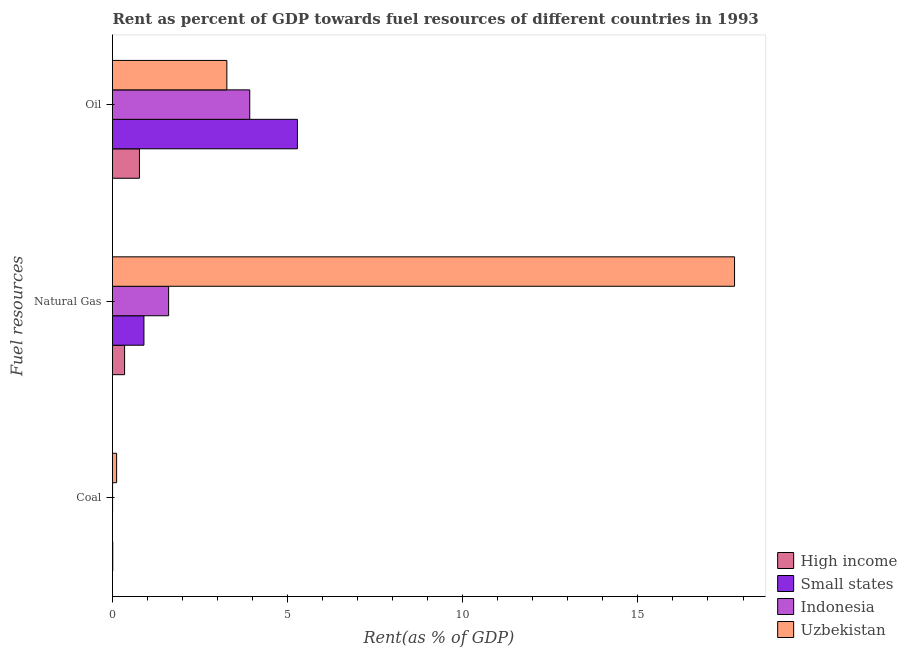How many different coloured bars are there?
Provide a short and direct response. 4. How many groups of bars are there?
Give a very brief answer. 3. Are the number of bars per tick equal to the number of legend labels?
Keep it short and to the point. Yes. Are the number of bars on each tick of the Y-axis equal?
Your answer should be very brief. Yes. How many bars are there on the 2nd tick from the bottom?
Provide a short and direct response. 4. What is the label of the 1st group of bars from the top?
Your response must be concise. Oil. What is the rent towards natural gas in High income?
Keep it short and to the point. 0.35. Across all countries, what is the maximum rent towards natural gas?
Offer a very short reply. 17.76. Across all countries, what is the minimum rent towards coal?
Your answer should be very brief. 0. In which country was the rent towards natural gas maximum?
Offer a very short reply. Uzbekistan. What is the total rent towards natural gas in the graph?
Make the answer very short. 20.6. What is the difference between the rent towards coal in Indonesia and that in High income?
Your answer should be very brief. -0. What is the difference between the rent towards natural gas in Uzbekistan and the rent towards coal in Small states?
Make the answer very short. 17.76. What is the average rent towards oil per country?
Offer a very short reply. 3.31. What is the difference between the rent towards natural gas and rent towards coal in High income?
Your answer should be compact. 0.34. In how many countries, is the rent towards coal greater than 1 %?
Provide a short and direct response. 0. What is the ratio of the rent towards natural gas in High income to that in Indonesia?
Offer a terse response. 0.22. Is the rent towards oil in Small states less than that in Uzbekistan?
Keep it short and to the point. No. What is the difference between the highest and the second highest rent towards oil?
Keep it short and to the point. 1.36. What is the difference between the highest and the lowest rent towards coal?
Provide a short and direct response. 0.12. In how many countries, is the rent towards coal greater than the average rent towards coal taken over all countries?
Make the answer very short. 1. Is the sum of the rent towards oil in Indonesia and Small states greater than the maximum rent towards coal across all countries?
Your answer should be very brief. Yes. What does the 1st bar from the top in Oil represents?
Make the answer very short. Uzbekistan. What does the 2nd bar from the bottom in Oil represents?
Keep it short and to the point. Small states. Is it the case that in every country, the sum of the rent towards coal and rent towards natural gas is greater than the rent towards oil?
Your answer should be very brief. No. What is the difference between two consecutive major ticks on the X-axis?
Provide a short and direct response. 5. Are the values on the major ticks of X-axis written in scientific E-notation?
Offer a very short reply. No. How many legend labels are there?
Offer a terse response. 4. What is the title of the graph?
Give a very brief answer. Rent as percent of GDP towards fuel resources of different countries in 1993. Does "Hungary" appear as one of the legend labels in the graph?
Your answer should be compact. No. What is the label or title of the X-axis?
Provide a short and direct response. Rent(as % of GDP). What is the label or title of the Y-axis?
Provide a succinct answer. Fuel resources. What is the Rent(as % of GDP) of High income in Coal?
Provide a short and direct response. 0.01. What is the Rent(as % of GDP) in Small states in Coal?
Your answer should be very brief. 0. What is the Rent(as % of GDP) of Indonesia in Coal?
Make the answer very short. 0. What is the Rent(as % of GDP) in Uzbekistan in Coal?
Provide a succinct answer. 0.12. What is the Rent(as % of GDP) of High income in Natural Gas?
Your answer should be very brief. 0.35. What is the Rent(as % of GDP) in Small states in Natural Gas?
Provide a short and direct response. 0.9. What is the Rent(as % of GDP) of Indonesia in Natural Gas?
Give a very brief answer. 1.6. What is the Rent(as % of GDP) of Uzbekistan in Natural Gas?
Offer a very short reply. 17.76. What is the Rent(as % of GDP) in High income in Oil?
Provide a succinct answer. 0.77. What is the Rent(as % of GDP) in Small states in Oil?
Ensure brevity in your answer.  5.28. What is the Rent(as % of GDP) in Indonesia in Oil?
Your answer should be very brief. 3.92. What is the Rent(as % of GDP) of Uzbekistan in Oil?
Keep it short and to the point. 3.26. Across all Fuel resources, what is the maximum Rent(as % of GDP) of High income?
Offer a terse response. 0.77. Across all Fuel resources, what is the maximum Rent(as % of GDP) in Small states?
Provide a succinct answer. 5.28. Across all Fuel resources, what is the maximum Rent(as % of GDP) in Indonesia?
Keep it short and to the point. 3.92. Across all Fuel resources, what is the maximum Rent(as % of GDP) of Uzbekistan?
Your response must be concise. 17.76. Across all Fuel resources, what is the minimum Rent(as % of GDP) in High income?
Offer a very short reply. 0.01. Across all Fuel resources, what is the minimum Rent(as % of GDP) of Small states?
Your answer should be very brief. 0. Across all Fuel resources, what is the minimum Rent(as % of GDP) in Indonesia?
Offer a very short reply. 0. Across all Fuel resources, what is the minimum Rent(as % of GDP) of Uzbekistan?
Your response must be concise. 0.12. What is the total Rent(as % of GDP) in High income in the graph?
Your answer should be very brief. 1.12. What is the total Rent(as % of GDP) of Small states in the graph?
Make the answer very short. 6.18. What is the total Rent(as % of GDP) in Indonesia in the graph?
Your answer should be very brief. 5.52. What is the total Rent(as % of GDP) in Uzbekistan in the graph?
Make the answer very short. 21.14. What is the difference between the Rent(as % of GDP) in High income in Coal and that in Natural Gas?
Your answer should be very brief. -0.34. What is the difference between the Rent(as % of GDP) in Small states in Coal and that in Natural Gas?
Your response must be concise. -0.9. What is the difference between the Rent(as % of GDP) of Indonesia in Coal and that in Natural Gas?
Keep it short and to the point. -1.6. What is the difference between the Rent(as % of GDP) of Uzbekistan in Coal and that in Natural Gas?
Your answer should be very brief. -17.64. What is the difference between the Rent(as % of GDP) in High income in Coal and that in Oil?
Give a very brief answer. -0.76. What is the difference between the Rent(as % of GDP) of Small states in Coal and that in Oil?
Your answer should be compact. -5.28. What is the difference between the Rent(as % of GDP) in Indonesia in Coal and that in Oil?
Give a very brief answer. -3.92. What is the difference between the Rent(as % of GDP) of Uzbekistan in Coal and that in Oil?
Provide a short and direct response. -3.15. What is the difference between the Rent(as % of GDP) in High income in Natural Gas and that in Oil?
Make the answer very short. -0.42. What is the difference between the Rent(as % of GDP) of Small states in Natural Gas and that in Oil?
Your answer should be compact. -4.38. What is the difference between the Rent(as % of GDP) in Indonesia in Natural Gas and that in Oil?
Your response must be concise. -2.32. What is the difference between the Rent(as % of GDP) of Uzbekistan in Natural Gas and that in Oil?
Your response must be concise. 14.49. What is the difference between the Rent(as % of GDP) of High income in Coal and the Rent(as % of GDP) of Small states in Natural Gas?
Offer a very short reply. -0.89. What is the difference between the Rent(as % of GDP) in High income in Coal and the Rent(as % of GDP) in Indonesia in Natural Gas?
Make the answer very short. -1.6. What is the difference between the Rent(as % of GDP) in High income in Coal and the Rent(as % of GDP) in Uzbekistan in Natural Gas?
Ensure brevity in your answer.  -17.75. What is the difference between the Rent(as % of GDP) of Small states in Coal and the Rent(as % of GDP) of Indonesia in Natural Gas?
Keep it short and to the point. -1.6. What is the difference between the Rent(as % of GDP) in Small states in Coal and the Rent(as % of GDP) in Uzbekistan in Natural Gas?
Give a very brief answer. -17.76. What is the difference between the Rent(as % of GDP) of Indonesia in Coal and the Rent(as % of GDP) of Uzbekistan in Natural Gas?
Your response must be concise. -17.76. What is the difference between the Rent(as % of GDP) of High income in Coal and the Rent(as % of GDP) of Small states in Oil?
Provide a short and direct response. -5.27. What is the difference between the Rent(as % of GDP) in High income in Coal and the Rent(as % of GDP) in Indonesia in Oil?
Provide a succinct answer. -3.91. What is the difference between the Rent(as % of GDP) of High income in Coal and the Rent(as % of GDP) of Uzbekistan in Oil?
Provide a short and direct response. -3.26. What is the difference between the Rent(as % of GDP) in Small states in Coal and the Rent(as % of GDP) in Indonesia in Oil?
Provide a succinct answer. -3.92. What is the difference between the Rent(as % of GDP) of Small states in Coal and the Rent(as % of GDP) of Uzbekistan in Oil?
Ensure brevity in your answer.  -3.26. What is the difference between the Rent(as % of GDP) of Indonesia in Coal and the Rent(as % of GDP) of Uzbekistan in Oil?
Offer a very short reply. -3.26. What is the difference between the Rent(as % of GDP) in High income in Natural Gas and the Rent(as % of GDP) in Small states in Oil?
Make the answer very short. -4.93. What is the difference between the Rent(as % of GDP) of High income in Natural Gas and the Rent(as % of GDP) of Indonesia in Oil?
Give a very brief answer. -3.57. What is the difference between the Rent(as % of GDP) of High income in Natural Gas and the Rent(as % of GDP) of Uzbekistan in Oil?
Offer a terse response. -2.92. What is the difference between the Rent(as % of GDP) of Small states in Natural Gas and the Rent(as % of GDP) of Indonesia in Oil?
Your answer should be very brief. -3.02. What is the difference between the Rent(as % of GDP) of Small states in Natural Gas and the Rent(as % of GDP) of Uzbekistan in Oil?
Ensure brevity in your answer.  -2.37. What is the difference between the Rent(as % of GDP) in Indonesia in Natural Gas and the Rent(as % of GDP) in Uzbekistan in Oil?
Provide a succinct answer. -1.66. What is the average Rent(as % of GDP) in High income per Fuel resources?
Give a very brief answer. 0.37. What is the average Rent(as % of GDP) of Small states per Fuel resources?
Offer a terse response. 2.06. What is the average Rent(as % of GDP) in Indonesia per Fuel resources?
Offer a terse response. 1.84. What is the average Rent(as % of GDP) in Uzbekistan per Fuel resources?
Give a very brief answer. 7.05. What is the difference between the Rent(as % of GDP) of High income and Rent(as % of GDP) of Small states in Coal?
Your response must be concise. 0.01. What is the difference between the Rent(as % of GDP) in High income and Rent(as % of GDP) in Indonesia in Coal?
Provide a succinct answer. 0. What is the difference between the Rent(as % of GDP) of High income and Rent(as % of GDP) of Uzbekistan in Coal?
Offer a very short reply. -0.11. What is the difference between the Rent(as % of GDP) in Small states and Rent(as % of GDP) in Indonesia in Coal?
Offer a terse response. -0. What is the difference between the Rent(as % of GDP) in Small states and Rent(as % of GDP) in Uzbekistan in Coal?
Keep it short and to the point. -0.12. What is the difference between the Rent(as % of GDP) in Indonesia and Rent(as % of GDP) in Uzbekistan in Coal?
Keep it short and to the point. -0.12. What is the difference between the Rent(as % of GDP) in High income and Rent(as % of GDP) in Small states in Natural Gas?
Keep it short and to the point. -0.55. What is the difference between the Rent(as % of GDP) of High income and Rent(as % of GDP) of Indonesia in Natural Gas?
Make the answer very short. -1.26. What is the difference between the Rent(as % of GDP) in High income and Rent(as % of GDP) in Uzbekistan in Natural Gas?
Ensure brevity in your answer.  -17.41. What is the difference between the Rent(as % of GDP) in Small states and Rent(as % of GDP) in Indonesia in Natural Gas?
Your response must be concise. -0.7. What is the difference between the Rent(as % of GDP) in Small states and Rent(as % of GDP) in Uzbekistan in Natural Gas?
Your answer should be very brief. -16.86. What is the difference between the Rent(as % of GDP) of Indonesia and Rent(as % of GDP) of Uzbekistan in Natural Gas?
Ensure brevity in your answer.  -16.16. What is the difference between the Rent(as % of GDP) of High income and Rent(as % of GDP) of Small states in Oil?
Your response must be concise. -4.51. What is the difference between the Rent(as % of GDP) in High income and Rent(as % of GDP) in Indonesia in Oil?
Offer a terse response. -3.15. What is the difference between the Rent(as % of GDP) of High income and Rent(as % of GDP) of Uzbekistan in Oil?
Make the answer very short. -2.5. What is the difference between the Rent(as % of GDP) of Small states and Rent(as % of GDP) of Indonesia in Oil?
Your response must be concise. 1.36. What is the difference between the Rent(as % of GDP) of Small states and Rent(as % of GDP) of Uzbekistan in Oil?
Offer a very short reply. 2.01. What is the difference between the Rent(as % of GDP) of Indonesia and Rent(as % of GDP) of Uzbekistan in Oil?
Provide a short and direct response. 0.65. What is the ratio of the Rent(as % of GDP) of High income in Coal to that in Natural Gas?
Your answer should be very brief. 0.02. What is the ratio of the Rent(as % of GDP) in Indonesia in Coal to that in Natural Gas?
Offer a very short reply. 0. What is the ratio of the Rent(as % of GDP) of Uzbekistan in Coal to that in Natural Gas?
Make the answer very short. 0.01. What is the ratio of the Rent(as % of GDP) of High income in Coal to that in Oil?
Your answer should be compact. 0.01. What is the ratio of the Rent(as % of GDP) of Small states in Coal to that in Oil?
Offer a terse response. 0. What is the ratio of the Rent(as % of GDP) of Uzbekistan in Coal to that in Oil?
Keep it short and to the point. 0.04. What is the ratio of the Rent(as % of GDP) in High income in Natural Gas to that in Oil?
Your answer should be very brief. 0.45. What is the ratio of the Rent(as % of GDP) of Small states in Natural Gas to that in Oil?
Make the answer very short. 0.17. What is the ratio of the Rent(as % of GDP) of Indonesia in Natural Gas to that in Oil?
Ensure brevity in your answer.  0.41. What is the ratio of the Rent(as % of GDP) in Uzbekistan in Natural Gas to that in Oil?
Offer a terse response. 5.44. What is the difference between the highest and the second highest Rent(as % of GDP) in High income?
Your response must be concise. 0.42. What is the difference between the highest and the second highest Rent(as % of GDP) of Small states?
Keep it short and to the point. 4.38. What is the difference between the highest and the second highest Rent(as % of GDP) in Indonesia?
Provide a succinct answer. 2.32. What is the difference between the highest and the second highest Rent(as % of GDP) in Uzbekistan?
Your answer should be compact. 14.49. What is the difference between the highest and the lowest Rent(as % of GDP) of High income?
Offer a terse response. 0.76. What is the difference between the highest and the lowest Rent(as % of GDP) in Small states?
Your answer should be compact. 5.28. What is the difference between the highest and the lowest Rent(as % of GDP) of Indonesia?
Provide a short and direct response. 3.92. What is the difference between the highest and the lowest Rent(as % of GDP) of Uzbekistan?
Your answer should be compact. 17.64. 